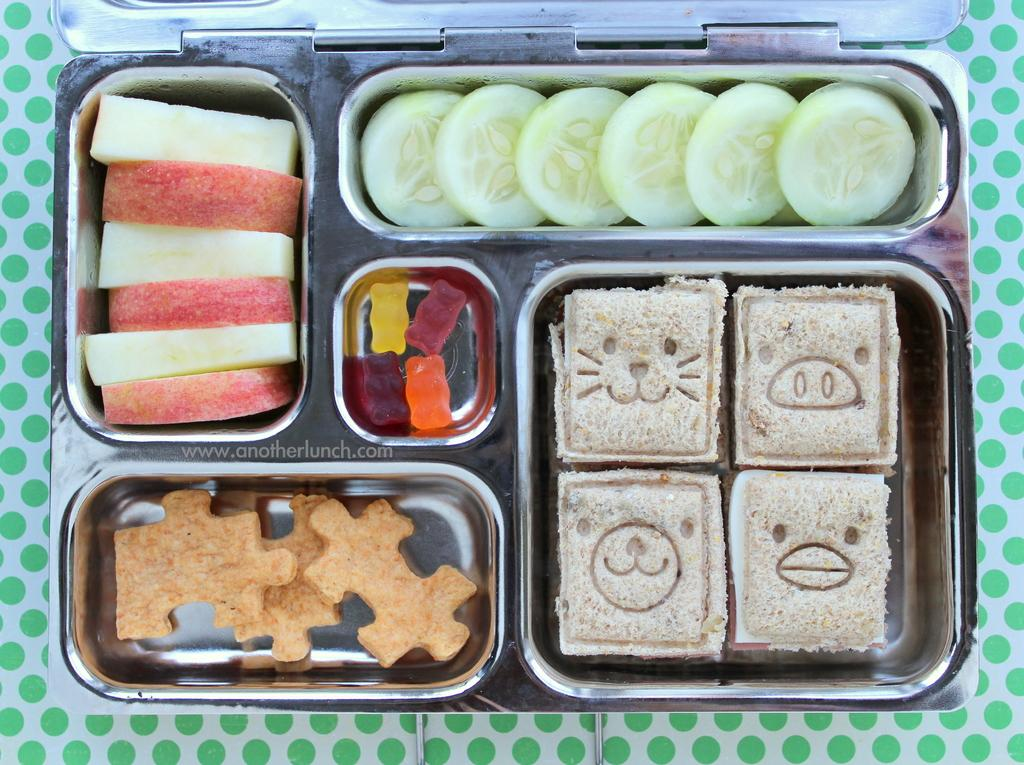What is present on the table in the image? There is a box on the table in the image. What is inside the box? The box contains cakes, vegetables, lollies, and biscuits. What type of glove can be seen on the table in the image? There is no glove present on the table in the image. How does the whip affect the movement of the cakes in the box? There is no whip present in the image, and the cakes are not moving. 